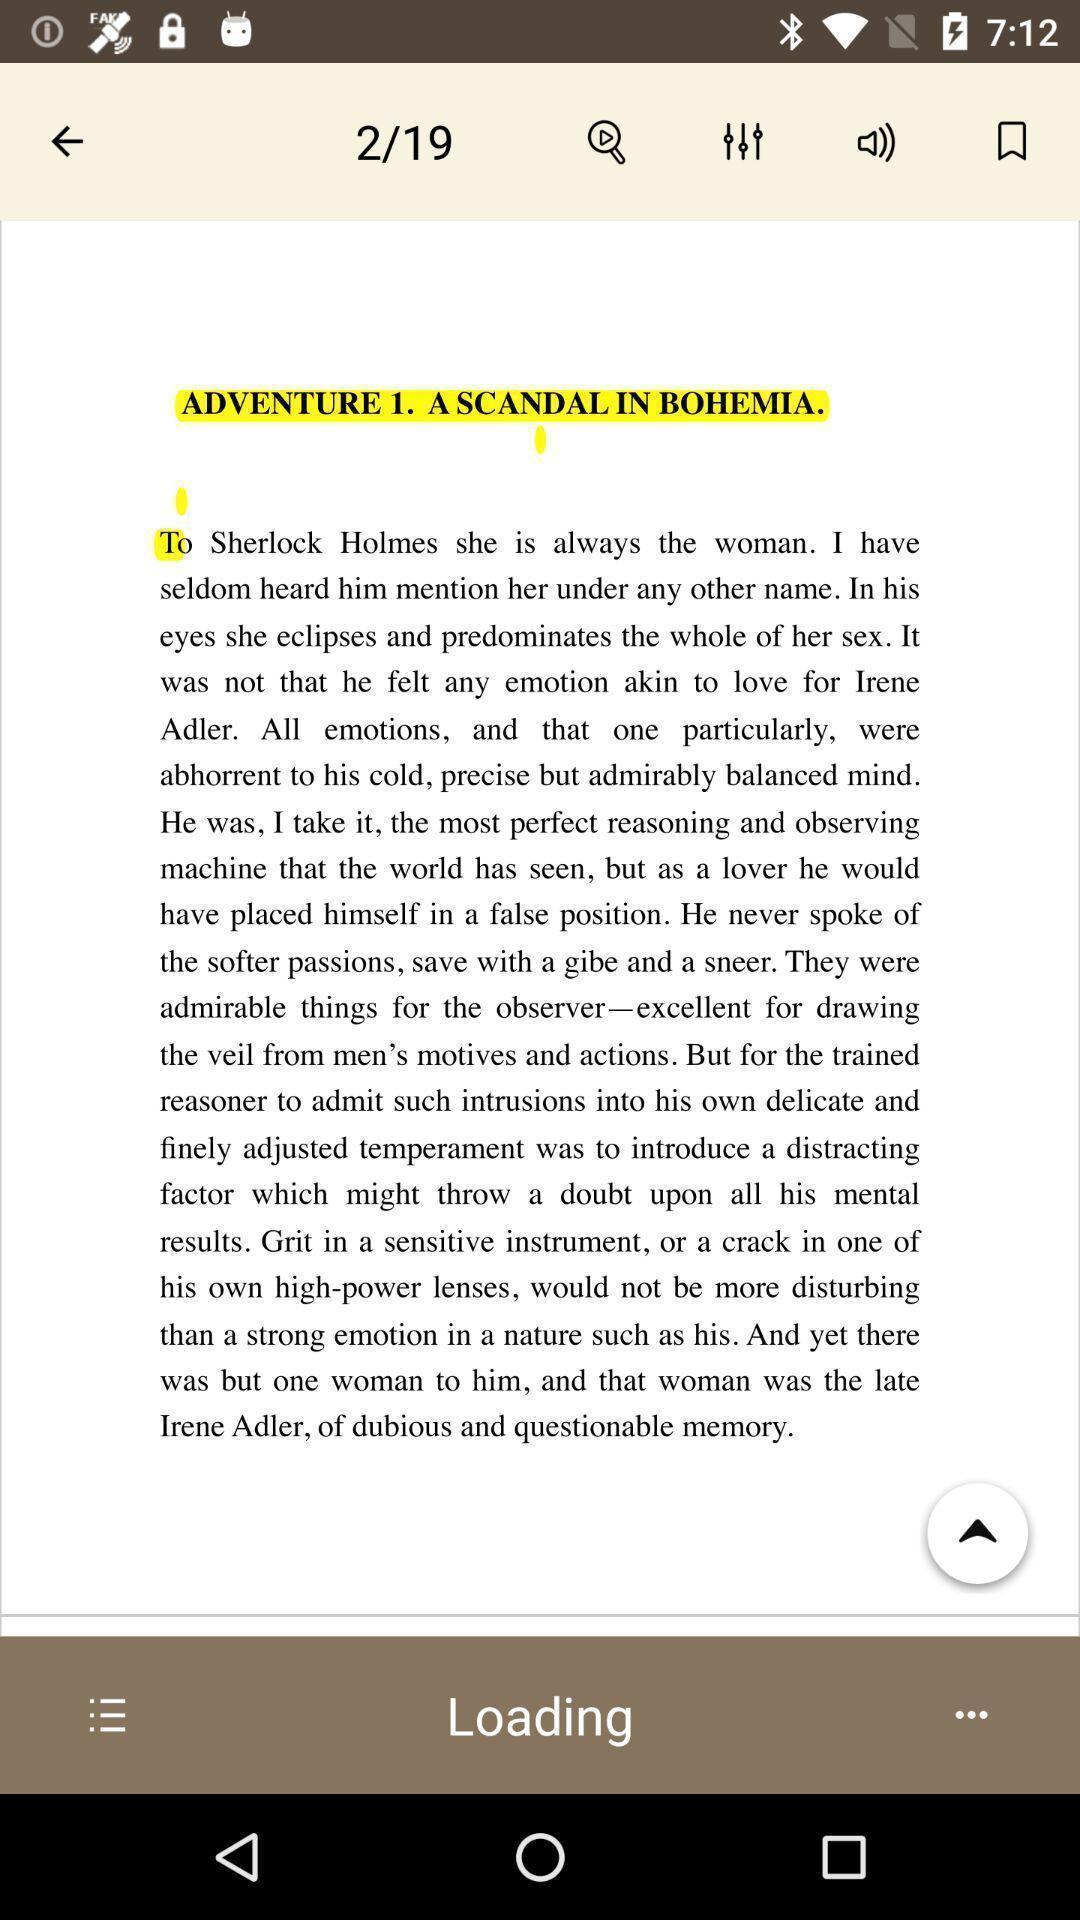Provide a description of this screenshot. Screen displaying an image with multiple control options. 